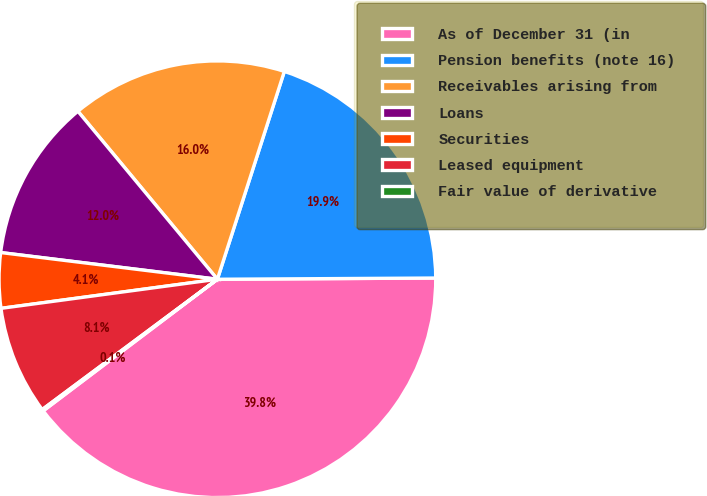Convert chart to OTSL. <chart><loc_0><loc_0><loc_500><loc_500><pie_chart><fcel>As of December 31 (in<fcel>Pension benefits (note 16)<fcel>Receivables arising from<fcel>Loans<fcel>Securities<fcel>Leased equipment<fcel>Fair value of derivative<nl><fcel>39.79%<fcel>19.95%<fcel>15.99%<fcel>12.02%<fcel>4.08%<fcel>8.05%<fcel>0.12%<nl></chart> 